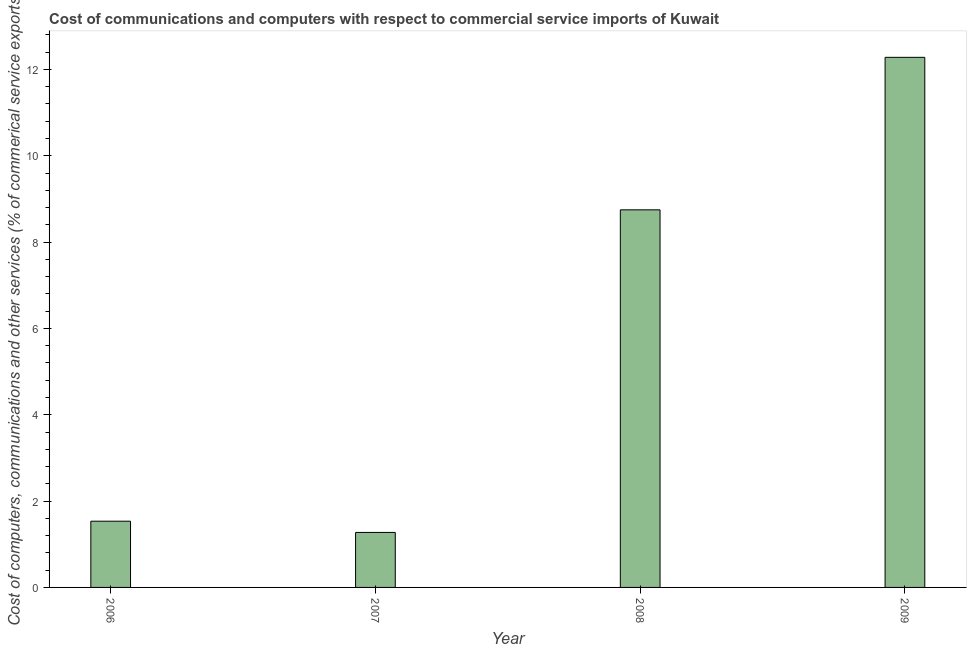Does the graph contain any zero values?
Offer a terse response. No. What is the title of the graph?
Your response must be concise. Cost of communications and computers with respect to commercial service imports of Kuwait. What is the label or title of the Y-axis?
Give a very brief answer. Cost of computers, communications and other services (% of commerical service exports). What is the cost of communications in 2008?
Provide a succinct answer. 8.75. Across all years, what is the maximum cost of communications?
Make the answer very short. 12.28. Across all years, what is the minimum cost of communications?
Ensure brevity in your answer.  1.27. What is the sum of the cost of communications?
Make the answer very short. 23.84. What is the difference between the cost of communications in 2008 and 2009?
Give a very brief answer. -3.53. What is the average cost of communications per year?
Keep it short and to the point. 5.96. What is the median  computer and other services?
Your answer should be very brief. 5.14. In how many years, is the  computer and other services greater than 3.2 %?
Your answer should be very brief. 2. What is the ratio of the cost of communications in 2006 to that in 2008?
Your answer should be very brief. 0.17. Is the cost of communications in 2007 less than that in 2008?
Your answer should be very brief. Yes. Is the difference between the  computer and other services in 2006 and 2008 greater than the difference between any two years?
Offer a very short reply. No. What is the difference between the highest and the second highest cost of communications?
Your response must be concise. 3.53. Is the sum of the cost of communications in 2006 and 2007 greater than the maximum cost of communications across all years?
Provide a short and direct response. No. What is the difference between the highest and the lowest  computer and other services?
Offer a very short reply. 11.01. In how many years, is the cost of communications greater than the average cost of communications taken over all years?
Keep it short and to the point. 2. What is the difference between two consecutive major ticks on the Y-axis?
Your answer should be compact. 2. Are the values on the major ticks of Y-axis written in scientific E-notation?
Your answer should be compact. No. What is the Cost of computers, communications and other services (% of commerical service exports) in 2006?
Provide a short and direct response. 1.53. What is the Cost of computers, communications and other services (% of commerical service exports) of 2007?
Give a very brief answer. 1.27. What is the Cost of computers, communications and other services (% of commerical service exports) in 2008?
Offer a terse response. 8.75. What is the Cost of computers, communications and other services (% of commerical service exports) in 2009?
Give a very brief answer. 12.28. What is the difference between the Cost of computers, communications and other services (% of commerical service exports) in 2006 and 2007?
Ensure brevity in your answer.  0.26. What is the difference between the Cost of computers, communications and other services (% of commerical service exports) in 2006 and 2008?
Give a very brief answer. -7.21. What is the difference between the Cost of computers, communications and other services (% of commerical service exports) in 2006 and 2009?
Offer a terse response. -10.75. What is the difference between the Cost of computers, communications and other services (% of commerical service exports) in 2007 and 2008?
Provide a short and direct response. -7.47. What is the difference between the Cost of computers, communications and other services (% of commerical service exports) in 2007 and 2009?
Keep it short and to the point. -11.01. What is the difference between the Cost of computers, communications and other services (% of commerical service exports) in 2008 and 2009?
Keep it short and to the point. -3.53. What is the ratio of the Cost of computers, communications and other services (% of commerical service exports) in 2006 to that in 2007?
Provide a short and direct response. 1.2. What is the ratio of the Cost of computers, communications and other services (% of commerical service exports) in 2006 to that in 2008?
Your response must be concise. 0.17. What is the ratio of the Cost of computers, communications and other services (% of commerical service exports) in 2007 to that in 2008?
Offer a very short reply. 0.15. What is the ratio of the Cost of computers, communications and other services (% of commerical service exports) in 2007 to that in 2009?
Provide a succinct answer. 0.1. What is the ratio of the Cost of computers, communications and other services (% of commerical service exports) in 2008 to that in 2009?
Offer a terse response. 0.71. 